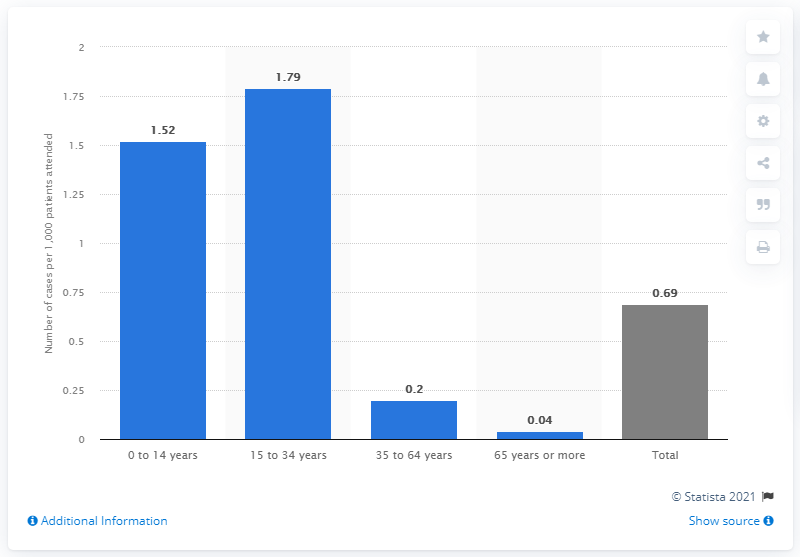Draw attention to some important aspects in this diagram. In 2017, the average number of infectious mononucleosis patients attended in Spain was 1.79 per person among those aged 15 to 34. 